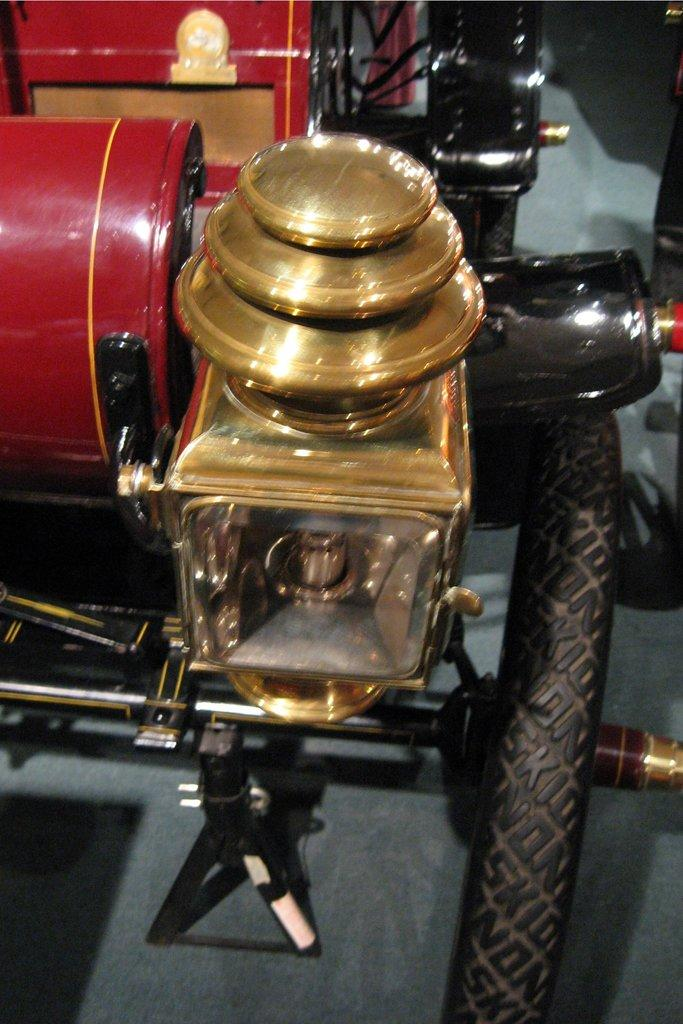What is the main subject in the image? There is a vehicle in the image. How does the duck feel about the vehicle in the image? There is no duck present in the image, so it is not possible to determine how a duck might feel about the vehicle. 